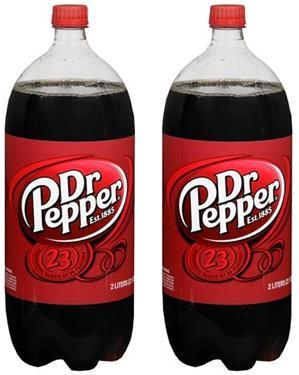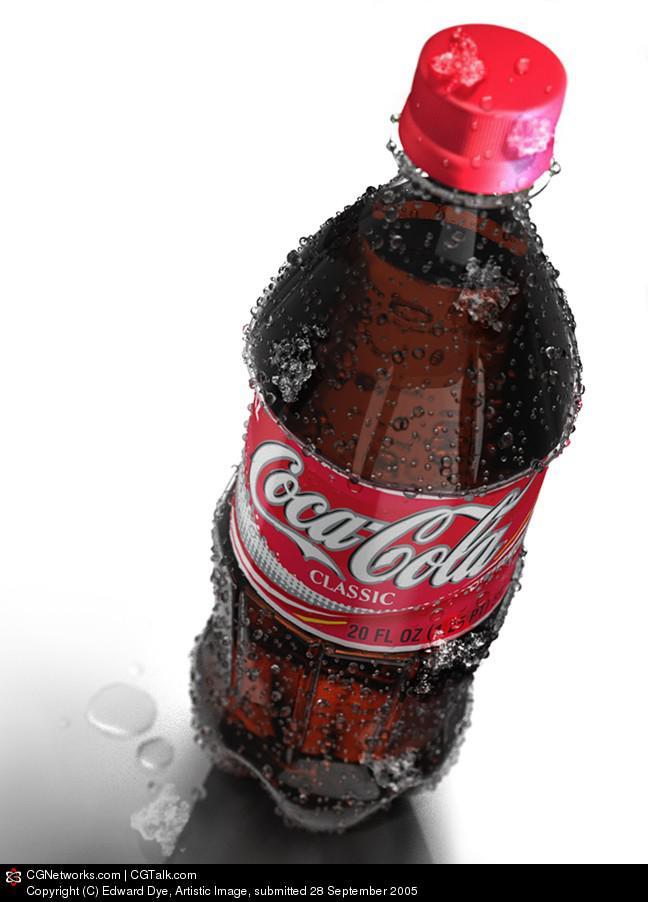The first image is the image on the left, the second image is the image on the right. Considering the images on both sides, is "There are no more than four bottles of soda." valid? Answer yes or no. Yes. The first image is the image on the left, the second image is the image on the right. For the images displayed, is the sentence "There is only one bottle in one of the images." factually correct? Answer yes or no. Yes. 